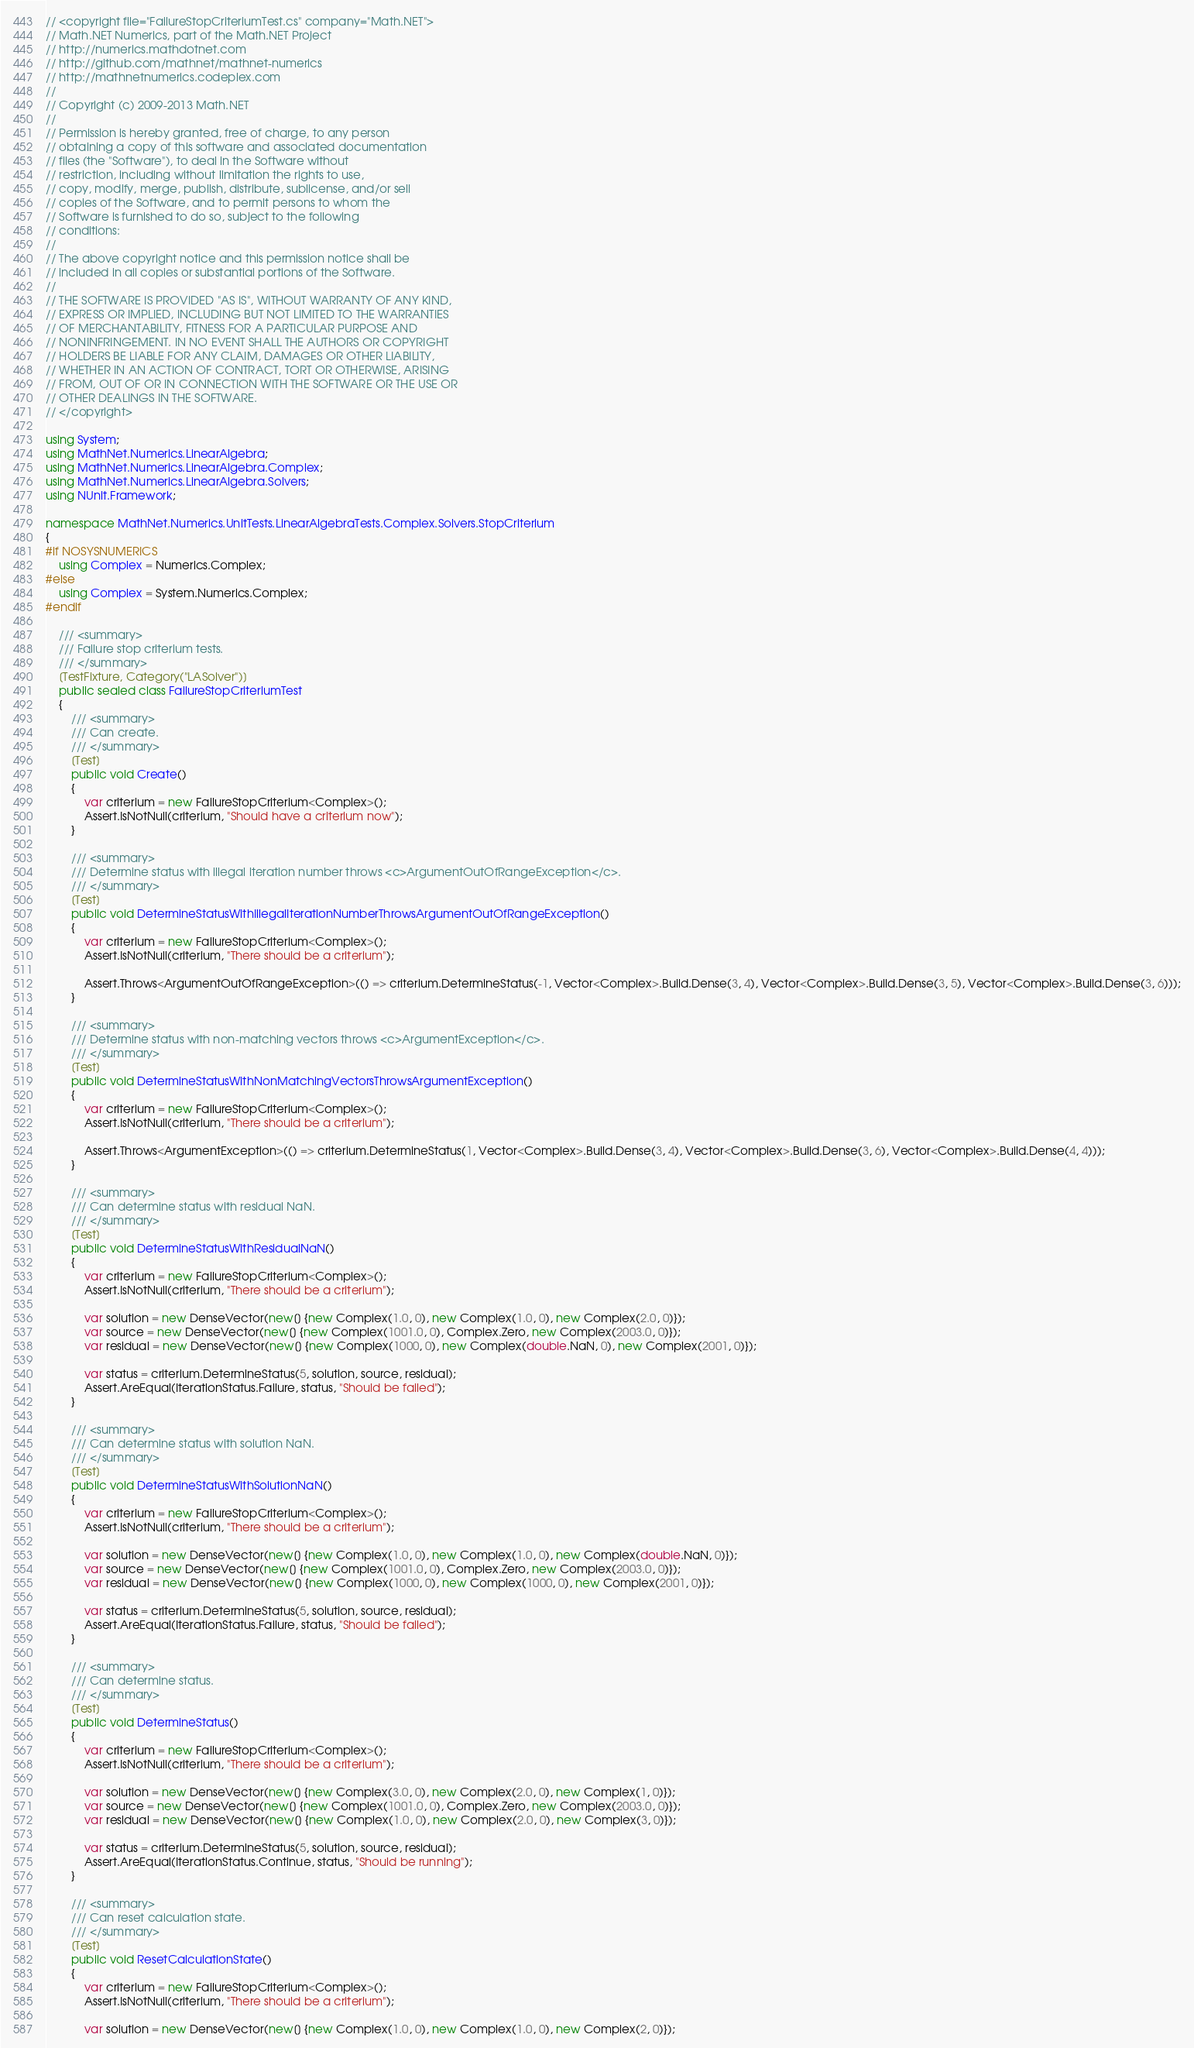Convert code to text. <code><loc_0><loc_0><loc_500><loc_500><_C#_>// <copyright file="FailureStopCriteriumTest.cs" company="Math.NET">
// Math.NET Numerics, part of the Math.NET Project
// http://numerics.mathdotnet.com
// http://github.com/mathnet/mathnet-numerics
// http://mathnetnumerics.codeplex.com
//
// Copyright (c) 2009-2013 Math.NET
//
// Permission is hereby granted, free of charge, to any person
// obtaining a copy of this software and associated documentation
// files (the "Software"), to deal in the Software without
// restriction, including without limitation the rights to use,
// copy, modify, merge, publish, distribute, sublicense, and/or sell
// copies of the Software, and to permit persons to whom the
// Software is furnished to do so, subject to the following
// conditions:
//
// The above copyright notice and this permission notice shall be
// included in all copies or substantial portions of the Software.
//
// THE SOFTWARE IS PROVIDED "AS IS", WITHOUT WARRANTY OF ANY KIND,
// EXPRESS OR IMPLIED, INCLUDING BUT NOT LIMITED TO THE WARRANTIES
// OF MERCHANTABILITY, FITNESS FOR A PARTICULAR PURPOSE AND
// NONINFRINGEMENT. IN NO EVENT SHALL THE AUTHORS OR COPYRIGHT
// HOLDERS BE LIABLE FOR ANY CLAIM, DAMAGES OR OTHER LIABILITY,
// WHETHER IN AN ACTION OF CONTRACT, TORT OR OTHERWISE, ARISING
// FROM, OUT OF OR IN CONNECTION WITH THE SOFTWARE OR THE USE OR
// OTHER DEALINGS IN THE SOFTWARE.
// </copyright>

using System;
using MathNet.Numerics.LinearAlgebra;
using MathNet.Numerics.LinearAlgebra.Complex;
using MathNet.Numerics.LinearAlgebra.Solvers;
using NUnit.Framework;

namespace MathNet.Numerics.UnitTests.LinearAlgebraTests.Complex.Solvers.StopCriterium
{
#if NOSYSNUMERICS
    using Complex = Numerics.Complex;
#else
    using Complex = System.Numerics.Complex;
#endif

    /// <summary>
    /// Failure stop criterium tests.
    /// </summary>
    [TestFixture, Category("LASolver")]
    public sealed class FailureStopCriteriumTest
    {
        /// <summary>
        /// Can create.
        /// </summary>
        [Test]
        public void Create()
        {
            var criterium = new FailureStopCriterium<Complex>();
            Assert.IsNotNull(criterium, "Should have a criterium now");
        }

        /// <summary>
        /// Determine status with illegal iteration number throws <c>ArgumentOutOfRangeException</c>.
        /// </summary>
        [Test]
        public void DetermineStatusWithIllegalIterationNumberThrowsArgumentOutOfRangeException()
        {
            var criterium = new FailureStopCriterium<Complex>();
            Assert.IsNotNull(criterium, "There should be a criterium");

            Assert.Throws<ArgumentOutOfRangeException>(() => criterium.DetermineStatus(-1, Vector<Complex>.Build.Dense(3, 4), Vector<Complex>.Build.Dense(3, 5), Vector<Complex>.Build.Dense(3, 6)));
        }

        /// <summary>
        /// Determine status with non-matching vectors throws <c>ArgumentException</c>.
        /// </summary>
        [Test]
        public void DetermineStatusWithNonMatchingVectorsThrowsArgumentException()
        {
            var criterium = new FailureStopCriterium<Complex>();
            Assert.IsNotNull(criterium, "There should be a criterium");

            Assert.Throws<ArgumentException>(() => criterium.DetermineStatus(1, Vector<Complex>.Build.Dense(3, 4), Vector<Complex>.Build.Dense(3, 6), Vector<Complex>.Build.Dense(4, 4)));
        }

        /// <summary>
        /// Can determine status with residual NaN.
        /// </summary>
        [Test]
        public void DetermineStatusWithResidualNaN()
        {
            var criterium = new FailureStopCriterium<Complex>();
            Assert.IsNotNull(criterium, "There should be a criterium");

            var solution = new DenseVector(new[] {new Complex(1.0, 0), new Complex(1.0, 0), new Complex(2.0, 0)});
            var source = new DenseVector(new[] {new Complex(1001.0, 0), Complex.Zero, new Complex(2003.0, 0)});
            var residual = new DenseVector(new[] {new Complex(1000, 0), new Complex(double.NaN, 0), new Complex(2001, 0)});

            var status = criterium.DetermineStatus(5, solution, source, residual);
            Assert.AreEqual(IterationStatus.Failure, status, "Should be failed");
        }

        /// <summary>
        /// Can determine status with solution NaN.
        /// </summary>
        [Test]
        public void DetermineStatusWithSolutionNaN()
        {
            var criterium = new FailureStopCriterium<Complex>();
            Assert.IsNotNull(criterium, "There should be a criterium");

            var solution = new DenseVector(new[] {new Complex(1.0, 0), new Complex(1.0, 0), new Complex(double.NaN, 0)});
            var source = new DenseVector(new[] {new Complex(1001.0, 0), Complex.Zero, new Complex(2003.0, 0)});
            var residual = new DenseVector(new[] {new Complex(1000, 0), new Complex(1000, 0), new Complex(2001, 0)});

            var status = criterium.DetermineStatus(5, solution, source, residual);
            Assert.AreEqual(IterationStatus.Failure, status, "Should be failed");
        }

        /// <summary>
        /// Can determine status.
        /// </summary>
        [Test]
        public void DetermineStatus()
        {
            var criterium = new FailureStopCriterium<Complex>();
            Assert.IsNotNull(criterium, "There should be a criterium");

            var solution = new DenseVector(new[] {new Complex(3.0, 0), new Complex(2.0, 0), new Complex(1, 0)});
            var source = new DenseVector(new[] {new Complex(1001.0, 0), Complex.Zero, new Complex(2003.0, 0)});
            var residual = new DenseVector(new[] {new Complex(1.0, 0), new Complex(2.0, 0), new Complex(3, 0)});

            var status = criterium.DetermineStatus(5, solution, source, residual);
            Assert.AreEqual(IterationStatus.Continue, status, "Should be running");
        }

        /// <summary>
        /// Can reset calculation state.
        /// </summary>
        [Test]
        public void ResetCalculationState()
        {
            var criterium = new FailureStopCriterium<Complex>();
            Assert.IsNotNull(criterium, "There should be a criterium");

            var solution = new DenseVector(new[] {new Complex(1.0, 0), new Complex(1.0, 0), new Complex(2, 0)});</code> 